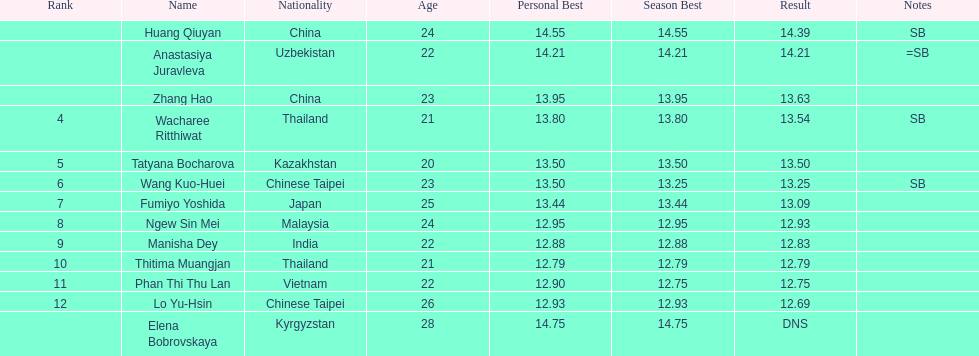How many people were ranked? 12. 